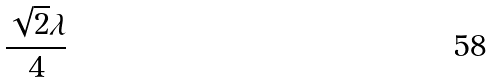<formula> <loc_0><loc_0><loc_500><loc_500>\frac { \sqrt { 2 } \lambda } { 4 }</formula> 